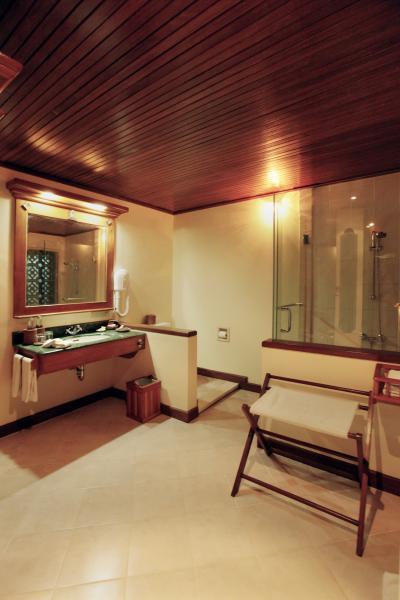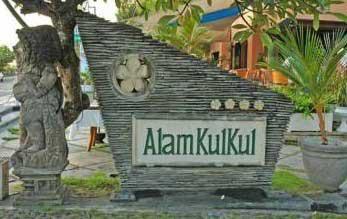The first image is the image on the left, the second image is the image on the right. Considering the images on both sides, is "The left and right image contains both an external view of the building and internal view of a resort." valid? Answer yes or no. Yes. The first image is the image on the left, the second image is the image on the right. Given the left and right images, does the statement "Both images are inside." hold true? Answer yes or no. No. 